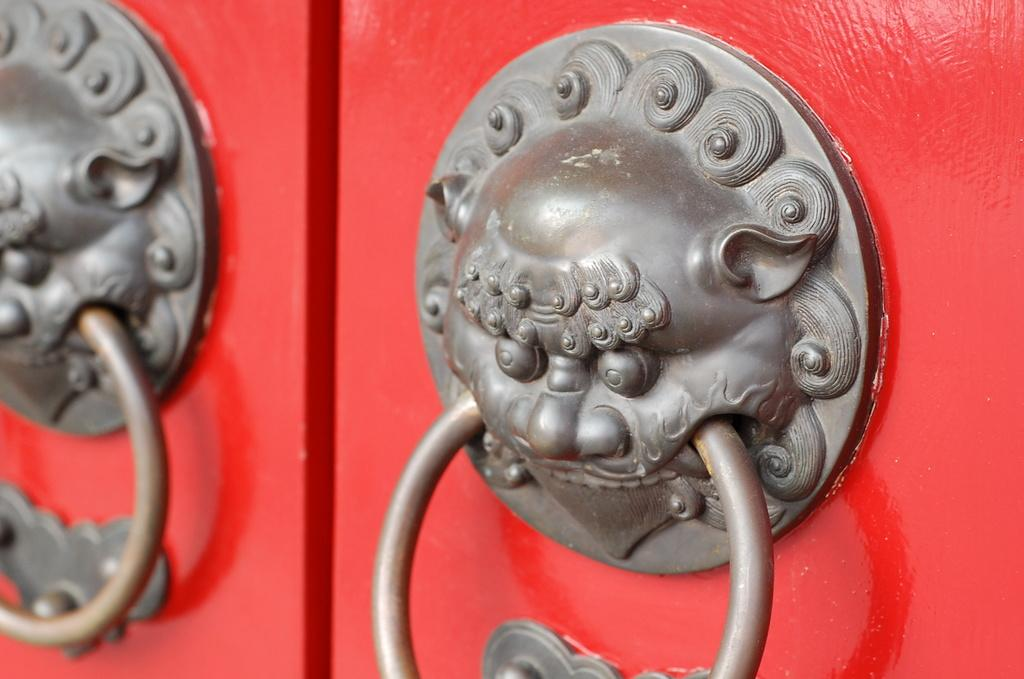What type of objects are present in the image? There are two metal knobs in the image. What are the metal knobs attached to? The metal knobs are attached to a red object. What does the red object resemble? The red object resembles a door. What type of story is being told by the bridge in the image? There is no bridge present in the image, so no story can be told by a bridge. 